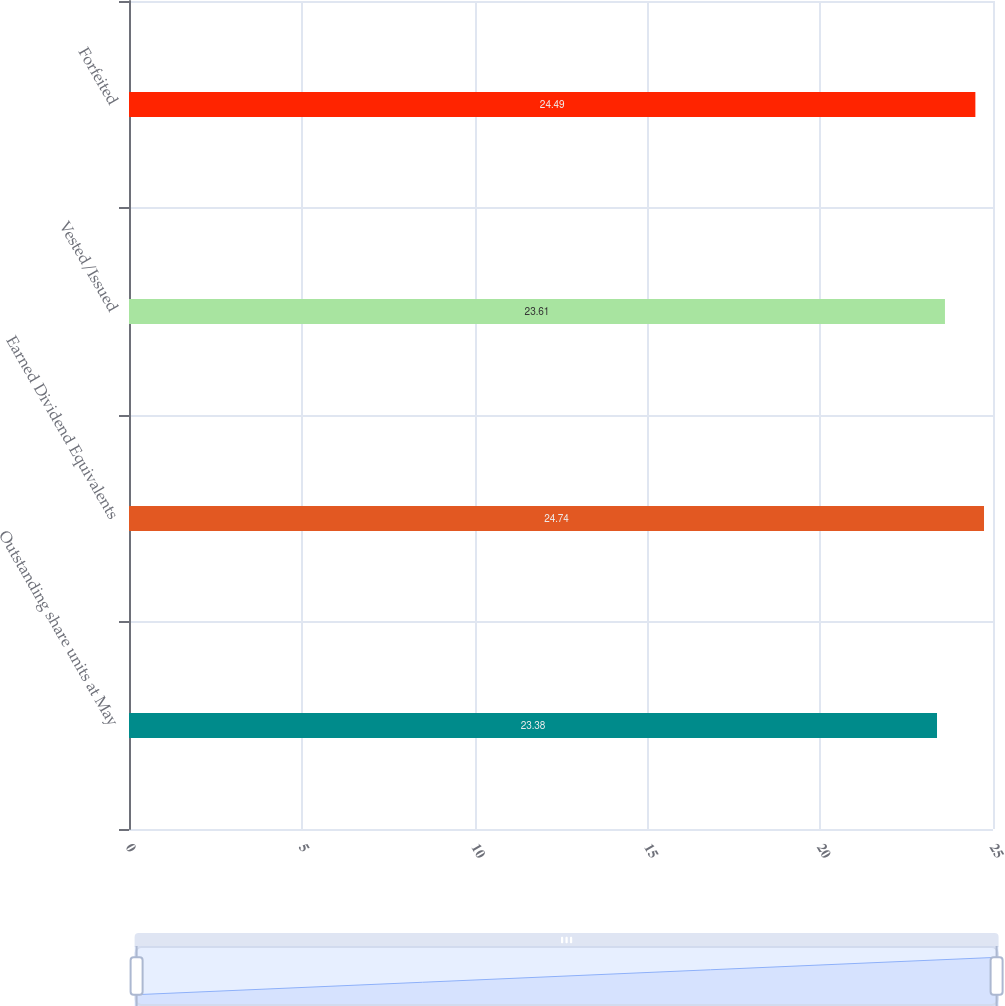<chart> <loc_0><loc_0><loc_500><loc_500><bar_chart><fcel>Outstanding share units at May<fcel>Earned Dividend Equivalents<fcel>Vested/Issued<fcel>Forfeited<nl><fcel>23.38<fcel>24.74<fcel>23.61<fcel>24.49<nl></chart> 